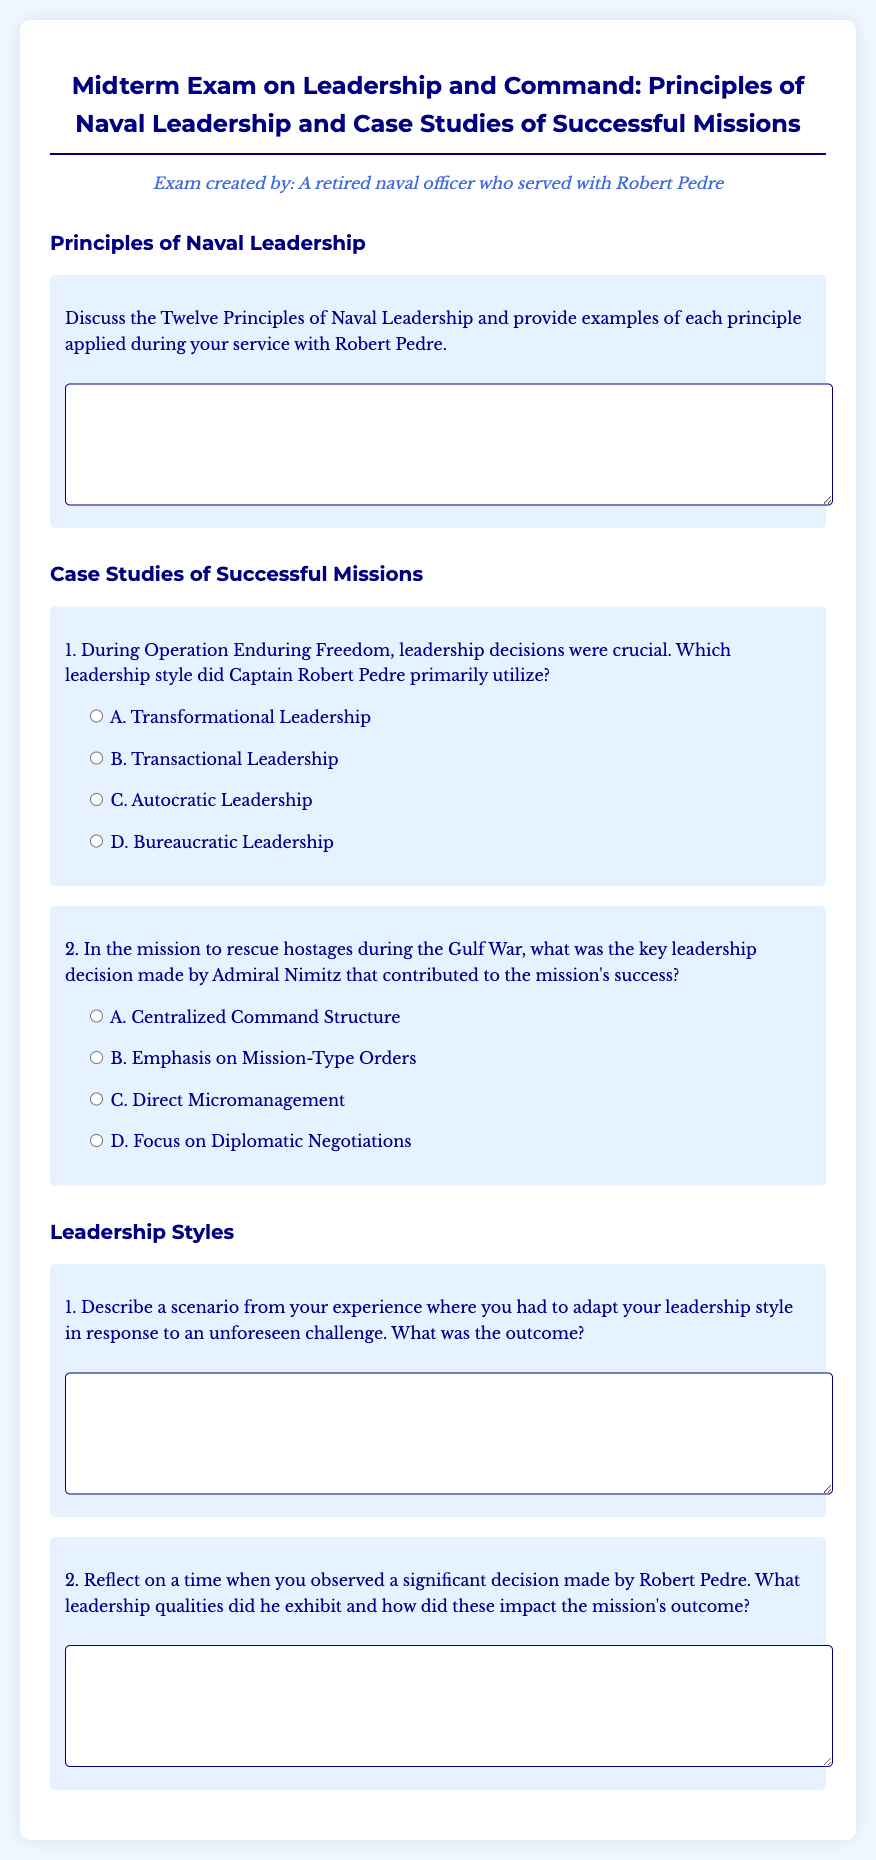What is the title of the exam? The title of the exam is stated at the beginning of the document.
Answer: Midterm Exam on Leadership and Command: Principles of Naval Leadership and Case Studies of Successful Missions Who is the creator of the exam? The creator's name is mentioned in the persona section of the document.
Answer: A retired naval officer who served with Robert Pedre How many principles of naval leadership are discussed? The document mentions discussing Twelve Principles of Naval Leadership.
Answer: Twelve Which leadership style did Captain Robert Pedre primarily utilize? The question about Pedre's leadership style provides multiple options from which the answer can be inferred.
Answer: A. Transformational Leadership What was the key leadership decision made by Admiral Nimitz during the Gulf War? The question outlines various options related to Nimitz's decision-making, which can be determined from the text.
Answer: B. Emphasis on Mission-Type Orders What is the first question under the "Leadership Styles" section? The document presents a specific question in this section which can be directly referenced.
Answer: Describe a scenario from your experience where you had to adapt your leadership style in response to an unforeseen challenge. What was the outcome? 